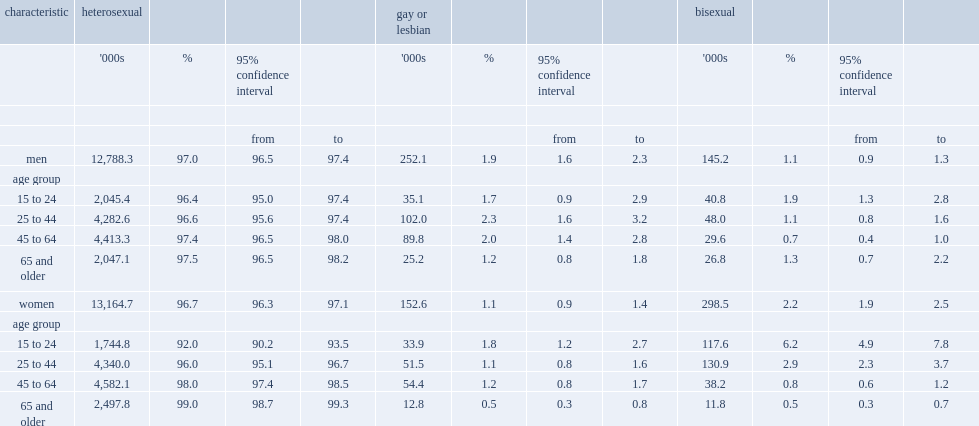What is the percentage of men identified as gay in 2015? 1.9. What is the percentage of men identified as bisexual in 2015? 1.1. What is the percentage of women identified as lesbian in 2015? 1.1. What is the percentage of women identified as bisexual in 2015? 2.2. Which sex are more likely to identify as homosexual in the 25-to-44 age groups, men or women? Men. Which sex are more likely to identify as homosexual in the 65-and-older age groups, men or women? Men. 